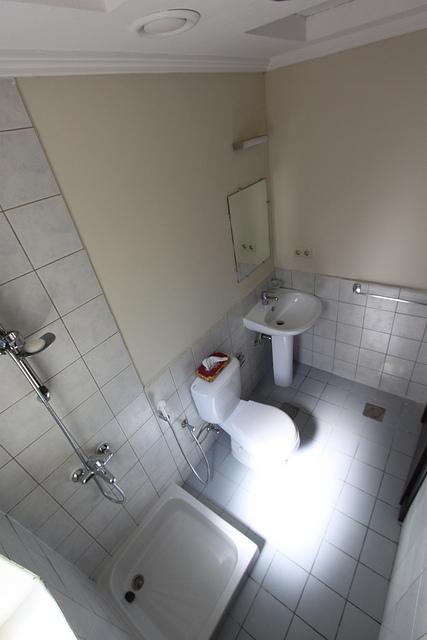Is the room a kitchen?
Concise answer only. No. Does the floor get wet when people shower here?
Write a very short answer. Yes. What room is this?
Be succinct. Bathroom. 